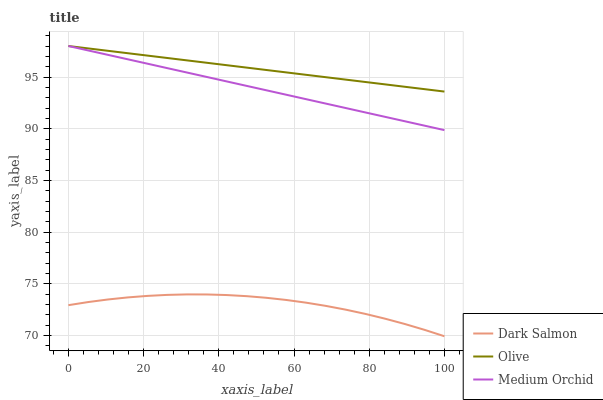Does Dark Salmon have the minimum area under the curve?
Answer yes or no. Yes. Does Olive have the maximum area under the curve?
Answer yes or no. Yes. Does Medium Orchid have the minimum area under the curve?
Answer yes or no. No. Does Medium Orchid have the maximum area under the curve?
Answer yes or no. No. Is Olive the smoothest?
Answer yes or no. Yes. Is Dark Salmon the roughest?
Answer yes or no. Yes. Is Medium Orchid the smoothest?
Answer yes or no. No. Is Medium Orchid the roughest?
Answer yes or no. No. Does Dark Salmon have the lowest value?
Answer yes or no. Yes. Does Medium Orchid have the lowest value?
Answer yes or no. No. Does Medium Orchid have the highest value?
Answer yes or no. Yes. Does Dark Salmon have the highest value?
Answer yes or no. No. Is Dark Salmon less than Olive?
Answer yes or no. Yes. Is Medium Orchid greater than Dark Salmon?
Answer yes or no. Yes. Does Olive intersect Medium Orchid?
Answer yes or no. Yes. Is Olive less than Medium Orchid?
Answer yes or no. No. Is Olive greater than Medium Orchid?
Answer yes or no. No. Does Dark Salmon intersect Olive?
Answer yes or no. No. 